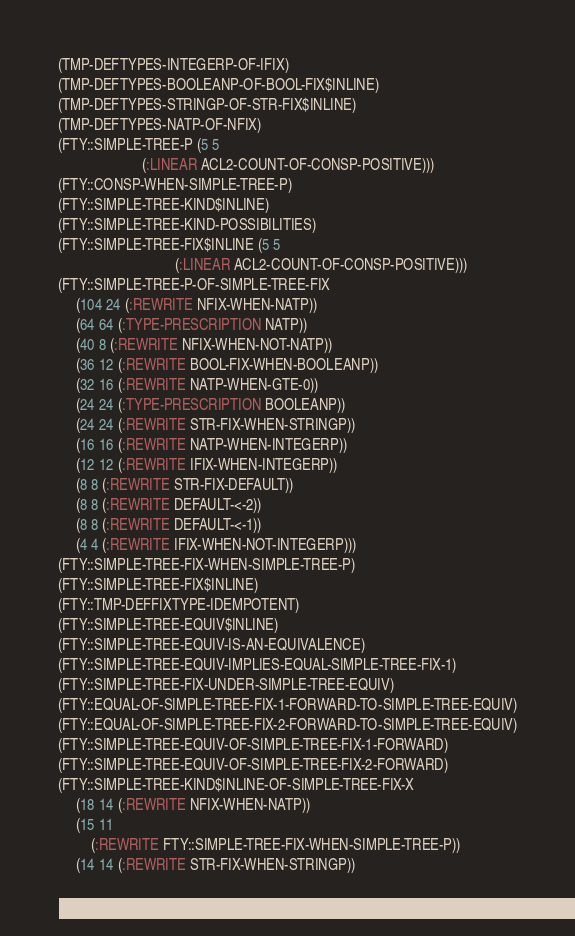Convert code to text. <code><loc_0><loc_0><loc_500><loc_500><_Lisp_>(TMP-DEFTYPES-INTEGERP-OF-IFIX)
(TMP-DEFTYPES-BOOLEANP-OF-BOOL-FIX$INLINE)
(TMP-DEFTYPES-STRINGP-OF-STR-FIX$INLINE)
(TMP-DEFTYPES-NATP-OF-NFIX)
(FTY::SIMPLE-TREE-P (5 5
                       (:LINEAR ACL2-COUNT-OF-CONSP-POSITIVE)))
(FTY::CONSP-WHEN-SIMPLE-TREE-P)
(FTY::SIMPLE-TREE-KIND$INLINE)
(FTY::SIMPLE-TREE-KIND-POSSIBILITIES)
(FTY::SIMPLE-TREE-FIX$INLINE (5 5
                                (:LINEAR ACL2-COUNT-OF-CONSP-POSITIVE)))
(FTY::SIMPLE-TREE-P-OF-SIMPLE-TREE-FIX
     (104 24 (:REWRITE NFIX-WHEN-NATP))
     (64 64 (:TYPE-PRESCRIPTION NATP))
     (40 8 (:REWRITE NFIX-WHEN-NOT-NATP))
     (36 12 (:REWRITE BOOL-FIX-WHEN-BOOLEANP))
     (32 16 (:REWRITE NATP-WHEN-GTE-0))
     (24 24 (:TYPE-PRESCRIPTION BOOLEANP))
     (24 24 (:REWRITE STR-FIX-WHEN-STRINGP))
     (16 16 (:REWRITE NATP-WHEN-INTEGERP))
     (12 12 (:REWRITE IFIX-WHEN-INTEGERP))
     (8 8 (:REWRITE STR-FIX-DEFAULT))
     (8 8 (:REWRITE DEFAULT-<-2))
     (8 8 (:REWRITE DEFAULT-<-1))
     (4 4 (:REWRITE IFIX-WHEN-NOT-INTEGERP)))
(FTY::SIMPLE-TREE-FIX-WHEN-SIMPLE-TREE-P)
(FTY::SIMPLE-TREE-FIX$INLINE)
(FTY::TMP-DEFFIXTYPE-IDEMPOTENT)
(FTY::SIMPLE-TREE-EQUIV$INLINE)
(FTY::SIMPLE-TREE-EQUIV-IS-AN-EQUIVALENCE)
(FTY::SIMPLE-TREE-EQUIV-IMPLIES-EQUAL-SIMPLE-TREE-FIX-1)
(FTY::SIMPLE-TREE-FIX-UNDER-SIMPLE-TREE-EQUIV)
(FTY::EQUAL-OF-SIMPLE-TREE-FIX-1-FORWARD-TO-SIMPLE-TREE-EQUIV)
(FTY::EQUAL-OF-SIMPLE-TREE-FIX-2-FORWARD-TO-SIMPLE-TREE-EQUIV)
(FTY::SIMPLE-TREE-EQUIV-OF-SIMPLE-TREE-FIX-1-FORWARD)
(FTY::SIMPLE-TREE-EQUIV-OF-SIMPLE-TREE-FIX-2-FORWARD)
(FTY::SIMPLE-TREE-KIND$INLINE-OF-SIMPLE-TREE-FIX-X
     (18 14 (:REWRITE NFIX-WHEN-NATP))
     (15 11
         (:REWRITE FTY::SIMPLE-TREE-FIX-WHEN-SIMPLE-TREE-P))
     (14 14 (:REWRITE STR-FIX-WHEN-STRINGP))</code> 